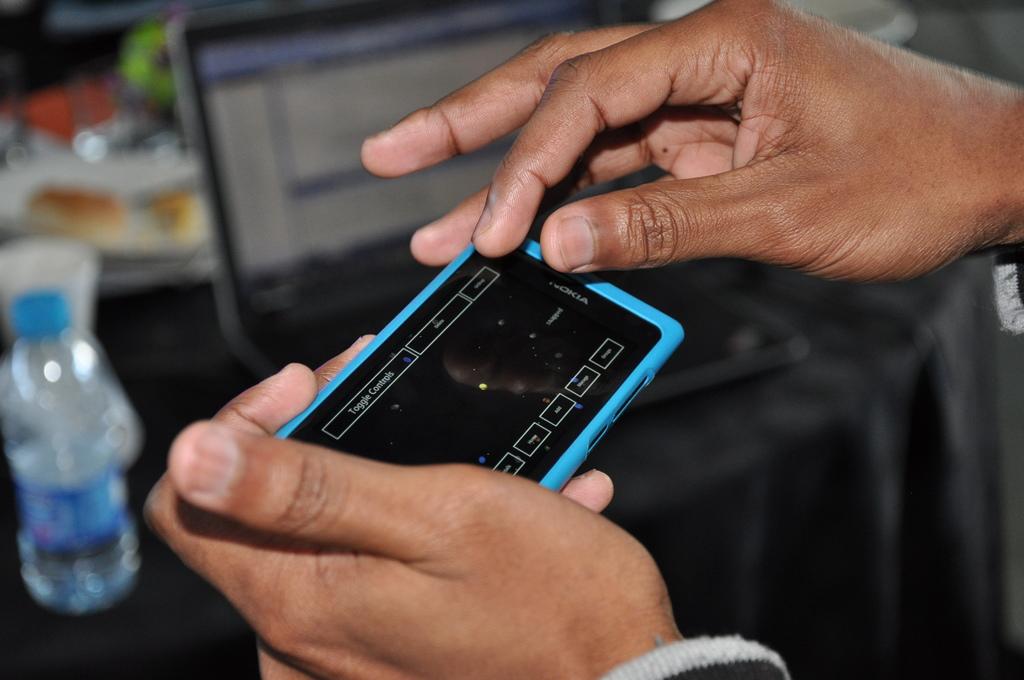What kind of phone is it?
Your answer should be compact. Nokia. 